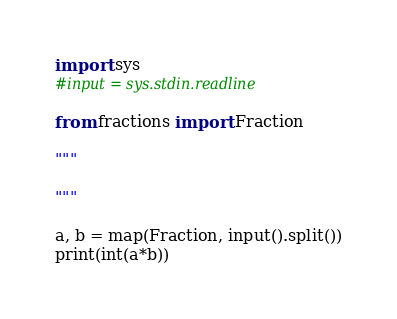Convert code to text. <code><loc_0><loc_0><loc_500><loc_500><_Python_>import sys
#input = sys.stdin.readline
 
from fractions import Fraction
 
"""
 
"""
 
a, b = map(Fraction, input().split())
print(int(a*b))</code> 